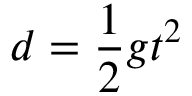<formula> <loc_0><loc_0><loc_500><loc_500>\ d = { \frac { 1 } { 2 } } g t ^ { 2 }</formula> 